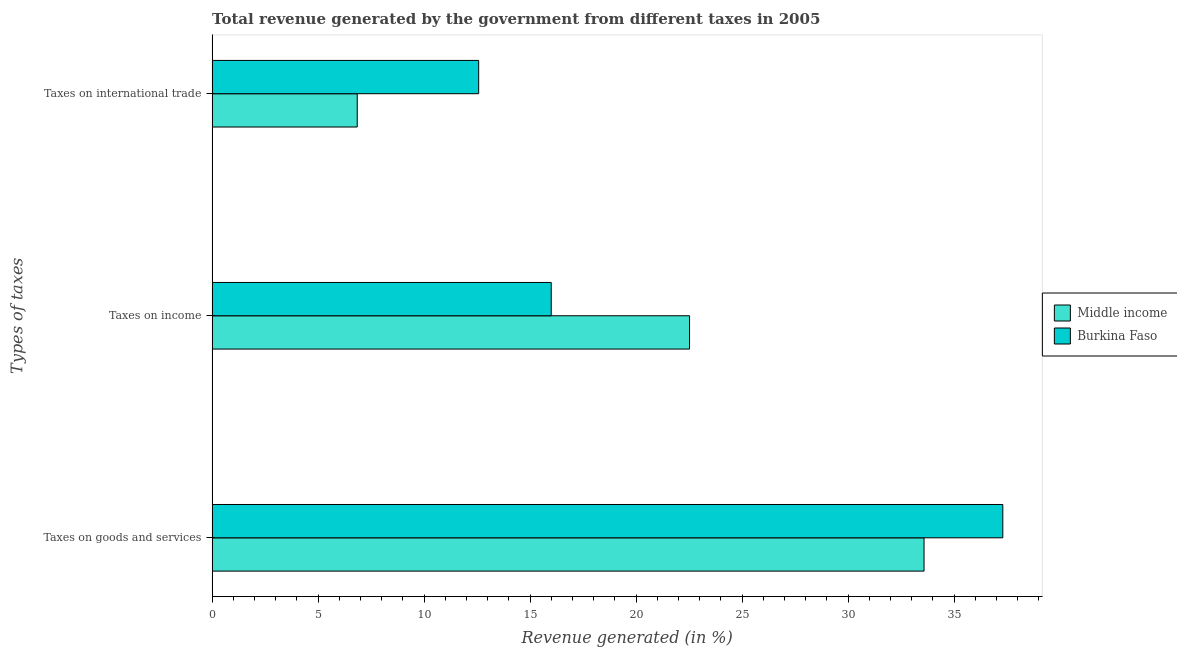How many different coloured bars are there?
Your answer should be compact. 2. Are the number of bars per tick equal to the number of legend labels?
Provide a succinct answer. Yes. Are the number of bars on each tick of the Y-axis equal?
Ensure brevity in your answer.  Yes. How many bars are there on the 2nd tick from the bottom?
Ensure brevity in your answer.  2. What is the label of the 2nd group of bars from the top?
Ensure brevity in your answer.  Taxes on income. What is the percentage of revenue generated by tax on international trade in Middle income?
Your answer should be compact. 6.84. Across all countries, what is the maximum percentage of revenue generated by taxes on goods and services?
Ensure brevity in your answer.  37.3. Across all countries, what is the minimum percentage of revenue generated by tax on international trade?
Ensure brevity in your answer.  6.84. In which country was the percentage of revenue generated by taxes on goods and services maximum?
Your response must be concise. Burkina Faso. In which country was the percentage of revenue generated by taxes on goods and services minimum?
Your response must be concise. Middle income. What is the total percentage of revenue generated by tax on international trade in the graph?
Offer a very short reply. 19.42. What is the difference between the percentage of revenue generated by taxes on goods and services in Middle income and that in Burkina Faso?
Offer a terse response. -3.72. What is the difference between the percentage of revenue generated by tax on international trade in Middle income and the percentage of revenue generated by taxes on goods and services in Burkina Faso?
Your answer should be very brief. -30.45. What is the average percentage of revenue generated by tax on international trade per country?
Offer a very short reply. 9.71. What is the difference between the percentage of revenue generated by taxes on income and percentage of revenue generated by tax on international trade in Middle income?
Offer a very short reply. 15.68. What is the ratio of the percentage of revenue generated by tax on international trade in Middle income to that in Burkina Faso?
Your response must be concise. 0.54. What is the difference between the highest and the second highest percentage of revenue generated by taxes on income?
Give a very brief answer. 6.52. What is the difference between the highest and the lowest percentage of revenue generated by taxes on income?
Your answer should be very brief. 6.52. Is the sum of the percentage of revenue generated by taxes on income in Burkina Faso and Middle income greater than the maximum percentage of revenue generated by taxes on goods and services across all countries?
Give a very brief answer. Yes. Is it the case that in every country, the sum of the percentage of revenue generated by taxes on goods and services and percentage of revenue generated by taxes on income is greater than the percentage of revenue generated by tax on international trade?
Offer a very short reply. Yes. Are all the bars in the graph horizontal?
Your answer should be very brief. Yes. How many countries are there in the graph?
Your answer should be compact. 2. Are the values on the major ticks of X-axis written in scientific E-notation?
Ensure brevity in your answer.  No. Does the graph contain any zero values?
Make the answer very short. No. Does the graph contain grids?
Make the answer very short. No. How are the legend labels stacked?
Your answer should be very brief. Vertical. What is the title of the graph?
Your response must be concise. Total revenue generated by the government from different taxes in 2005. What is the label or title of the X-axis?
Give a very brief answer. Revenue generated (in %). What is the label or title of the Y-axis?
Your response must be concise. Types of taxes. What is the Revenue generated (in %) of Middle income in Taxes on goods and services?
Your answer should be compact. 33.58. What is the Revenue generated (in %) of Burkina Faso in Taxes on goods and services?
Provide a succinct answer. 37.3. What is the Revenue generated (in %) of Middle income in Taxes on income?
Offer a very short reply. 22.52. What is the Revenue generated (in %) in Burkina Faso in Taxes on income?
Make the answer very short. 16. What is the Revenue generated (in %) of Middle income in Taxes on international trade?
Keep it short and to the point. 6.84. What is the Revenue generated (in %) in Burkina Faso in Taxes on international trade?
Offer a terse response. 12.57. Across all Types of taxes, what is the maximum Revenue generated (in %) in Middle income?
Offer a very short reply. 33.58. Across all Types of taxes, what is the maximum Revenue generated (in %) of Burkina Faso?
Provide a succinct answer. 37.3. Across all Types of taxes, what is the minimum Revenue generated (in %) in Middle income?
Ensure brevity in your answer.  6.84. Across all Types of taxes, what is the minimum Revenue generated (in %) in Burkina Faso?
Provide a succinct answer. 12.57. What is the total Revenue generated (in %) in Middle income in the graph?
Make the answer very short. 62.95. What is the total Revenue generated (in %) in Burkina Faso in the graph?
Offer a terse response. 65.86. What is the difference between the Revenue generated (in %) of Middle income in Taxes on goods and services and that in Taxes on income?
Make the answer very short. 11.06. What is the difference between the Revenue generated (in %) in Burkina Faso in Taxes on goods and services and that in Taxes on income?
Provide a short and direct response. 21.3. What is the difference between the Revenue generated (in %) of Middle income in Taxes on goods and services and that in Taxes on international trade?
Your response must be concise. 26.74. What is the difference between the Revenue generated (in %) in Burkina Faso in Taxes on goods and services and that in Taxes on international trade?
Keep it short and to the point. 24.72. What is the difference between the Revenue generated (in %) of Middle income in Taxes on income and that in Taxes on international trade?
Your response must be concise. 15.68. What is the difference between the Revenue generated (in %) in Burkina Faso in Taxes on income and that in Taxes on international trade?
Give a very brief answer. 3.42. What is the difference between the Revenue generated (in %) of Middle income in Taxes on goods and services and the Revenue generated (in %) of Burkina Faso in Taxes on income?
Your answer should be very brief. 17.58. What is the difference between the Revenue generated (in %) of Middle income in Taxes on goods and services and the Revenue generated (in %) of Burkina Faso in Taxes on international trade?
Provide a short and direct response. 21.01. What is the difference between the Revenue generated (in %) in Middle income in Taxes on income and the Revenue generated (in %) in Burkina Faso in Taxes on international trade?
Make the answer very short. 9.95. What is the average Revenue generated (in %) of Middle income per Types of taxes?
Provide a short and direct response. 20.98. What is the average Revenue generated (in %) of Burkina Faso per Types of taxes?
Provide a succinct answer. 21.95. What is the difference between the Revenue generated (in %) in Middle income and Revenue generated (in %) in Burkina Faso in Taxes on goods and services?
Your response must be concise. -3.72. What is the difference between the Revenue generated (in %) of Middle income and Revenue generated (in %) of Burkina Faso in Taxes on income?
Keep it short and to the point. 6.52. What is the difference between the Revenue generated (in %) in Middle income and Revenue generated (in %) in Burkina Faso in Taxes on international trade?
Offer a terse response. -5.73. What is the ratio of the Revenue generated (in %) of Middle income in Taxes on goods and services to that in Taxes on income?
Provide a short and direct response. 1.49. What is the ratio of the Revenue generated (in %) in Burkina Faso in Taxes on goods and services to that in Taxes on income?
Provide a short and direct response. 2.33. What is the ratio of the Revenue generated (in %) in Middle income in Taxes on goods and services to that in Taxes on international trade?
Provide a short and direct response. 4.91. What is the ratio of the Revenue generated (in %) in Burkina Faso in Taxes on goods and services to that in Taxes on international trade?
Provide a succinct answer. 2.97. What is the ratio of the Revenue generated (in %) of Middle income in Taxes on income to that in Taxes on international trade?
Offer a very short reply. 3.29. What is the ratio of the Revenue generated (in %) in Burkina Faso in Taxes on income to that in Taxes on international trade?
Offer a terse response. 1.27. What is the difference between the highest and the second highest Revenue generated (in %) of Middle income?
Provide a short and direct response. 11.06. What is the difference between the highest and the second highest Revenue generated (in %) of Burkina Faso?
Offer a very short reply. 21.3. What is the difference between the highest and the lowest Revenue generated (in %) in Middle income?
Your response must be concise. 26.74. What is the difference between the highest and the lowest Revenue generated (in %) in Burkina Faso?
Make the answer very short. 24.72. 